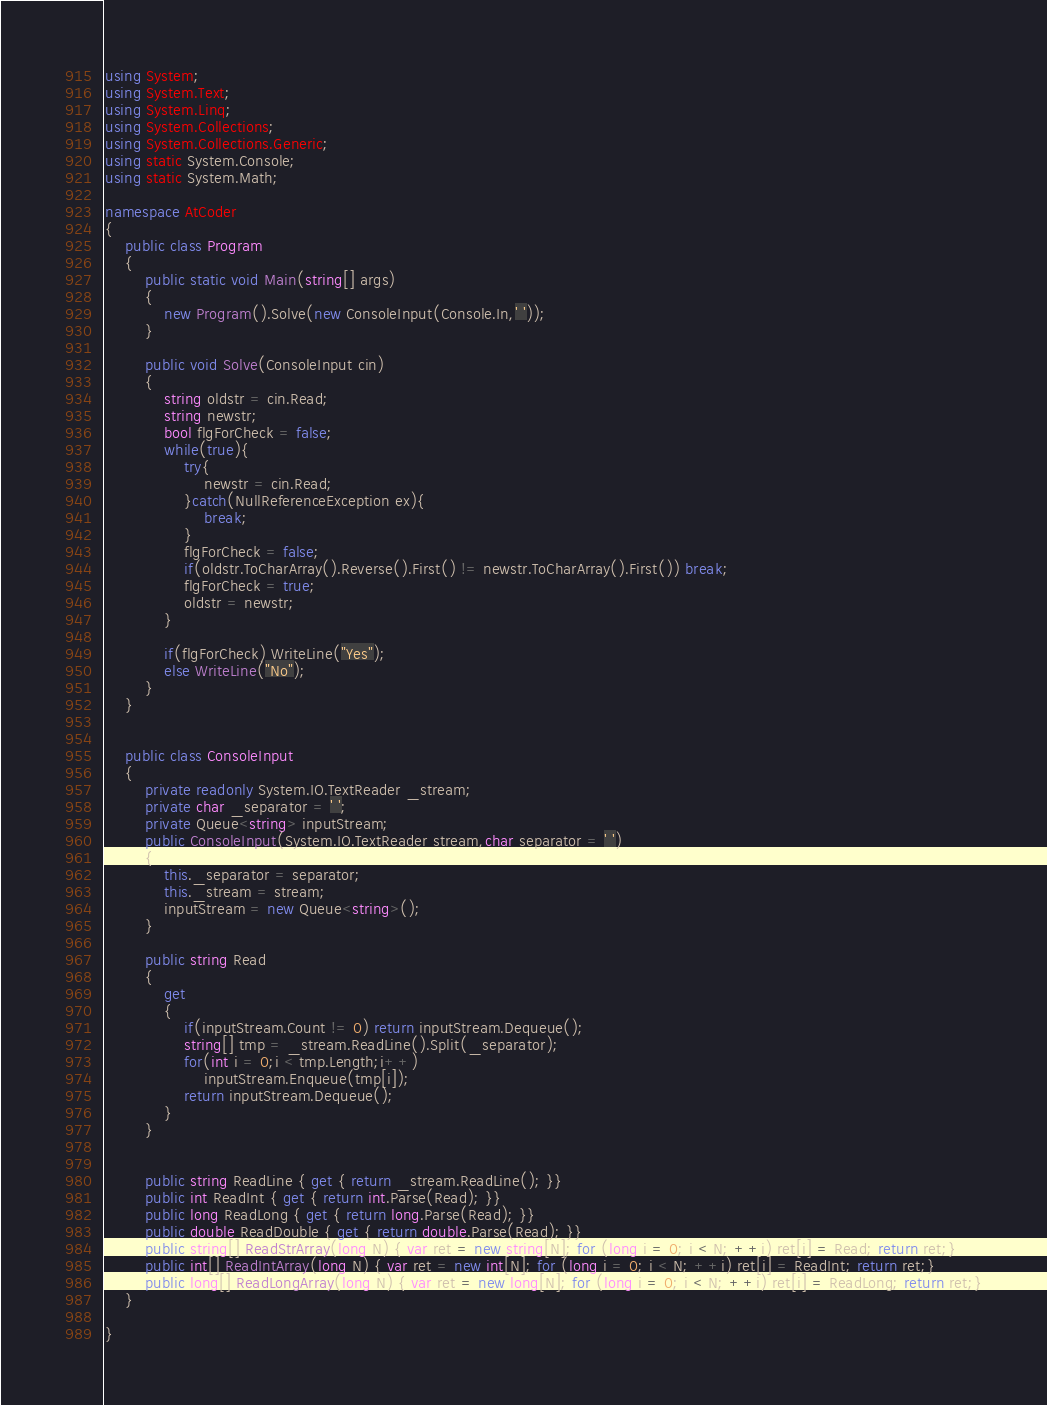<code> <loc_0><loc_0><loc_500><loc_500><_C#_>using System;
using System.Text;
using System.Linq;
using System.Collections;
using System.Collections.Generic;
using static System.Console;
using static System.Math;

namespace AtCoder
{
    public class Program
    {
        public static void Main(string[] args)
        {
            new Program().Solve(new ConsoleInput(Console.In,' '));
        }

        public void Solve(ConsoleInput cin)
        {
            string oldstr = cin.Read;
            string newstr;
            bool flgForCheck = false;
            while(true){
                try{
                    newstr = cin.Read;
                }catch(NullReferenceException ex){
                    break;
                }
                flgForCheck = false;
                if(oldstr.ToCharArray().Reverse().First() != newstr.ToCharArray().First()) break;
                flgForCheck = true;
                oldstr = newstr;
            }
            
            if(flgForCheck) WriteLine("Yes");
            else WriteLine("No");
        }
    }


    public class ConsoleInput
    {
        private readonly System.IO.TextReader _stream;
        private char _separator = ' ';
        private Queue<string> inputStream;
        public ConsoleInput(System.IO.TextReader stream,char separator = ' ')
        {
            this._separator = separator;
            this._stream = stream;
            inputStream = new Queue<string>();
        }

        public string Read
        {
            get
            {
                if(inputStream.Count != 0) return inputStream.Dequeue();
                string[] tmp = _stream.ReadLine().Split(_separator);
                for(int i = 0;i < tmp.Length;i++)
                    inputStream.Enqueue(tmp[i]);
                return inputStream.Dequeue();
            }
        }

        
        public string ReadLine { get { return _stream.ReadLine(); }}
        public int ReadInt { get { return int.Parse(Read); }}
        public long ReadLong { get { return long.Parse(Read); }}
        public double ReadDouble { get { return double.Parse(Read); }}
        public string[] ReadStrArray(long N) { var ret = new string[N]; for (long i = 0; i < N; ++i) ret[i] = Read; return ret;}
        public int[] ReadIntArray(long N) { var ret = new int[N]; for (long i = 0; i < N; ++i) ret[i] = ReadInt; return ret;}
        public long[] ReadLongArray(long N) { var ret = new long[N]; for (long i = 0; i < N; ++i) ret[i] = ReadLong; return ret;}
    }

}</code> 